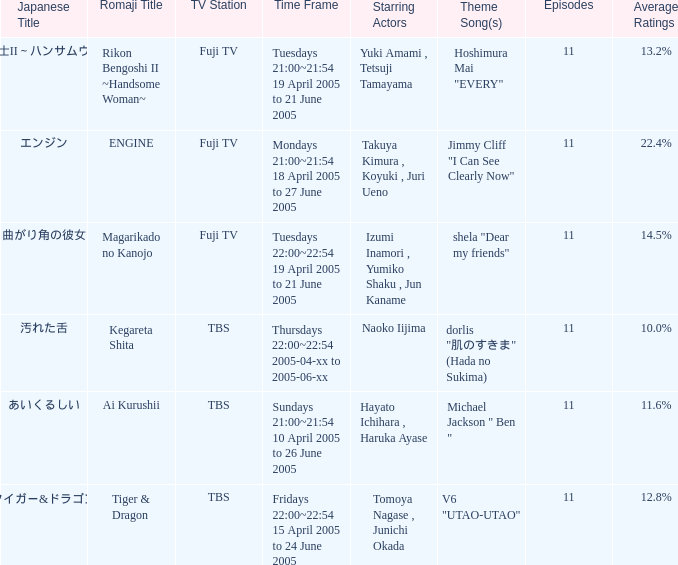What is the opening track for magarikado no kanojo? Shela "dear my friends". 